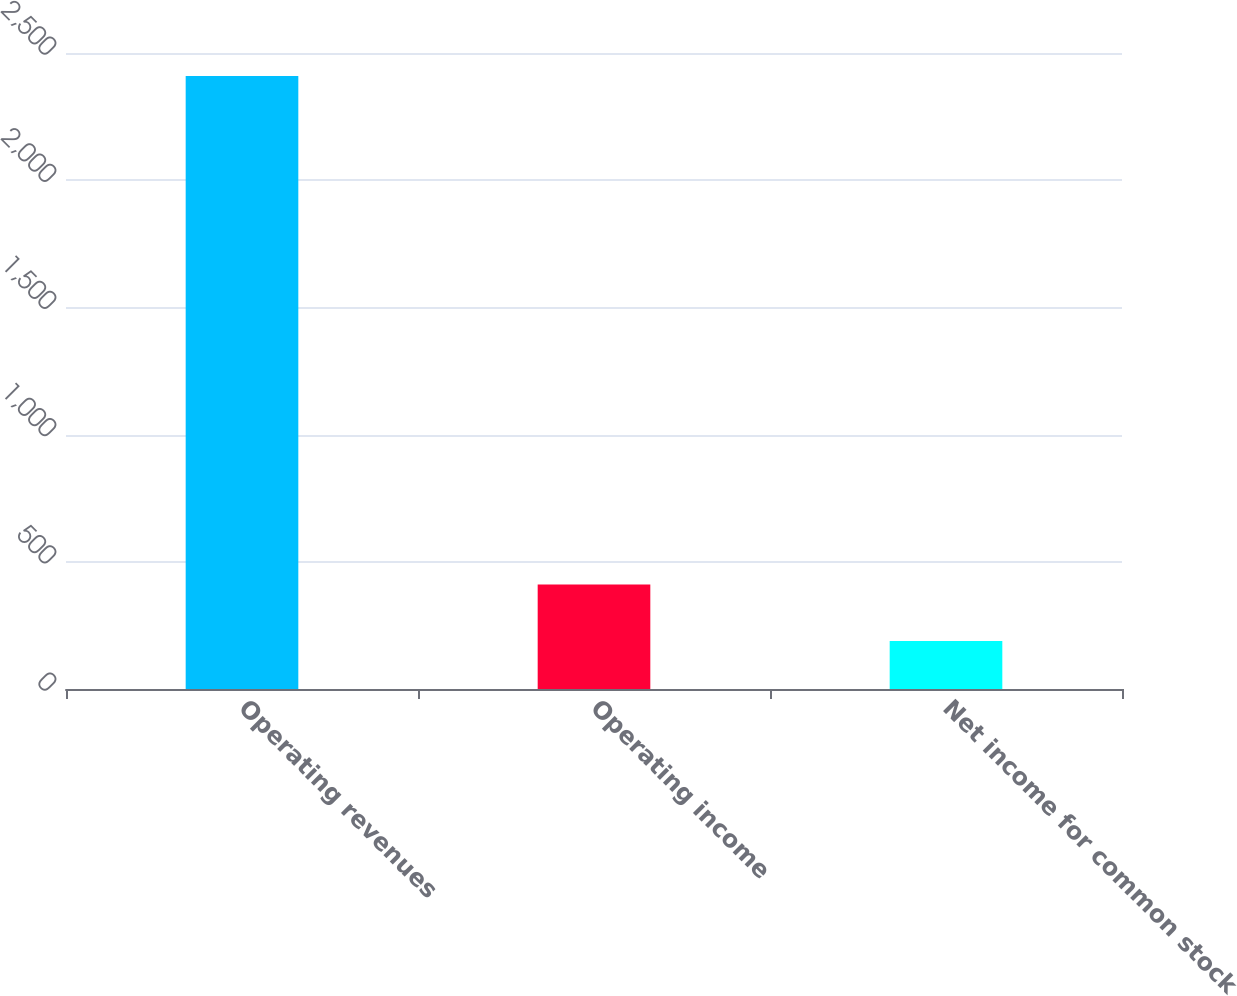<chart> <loc_0><loc_0><loc_500><loc_500><bar_chart><fcel>Operating revenues<fcel>Operating income<fcel>Net income for common stock<nl><fcel>2410<fcel>411.1<fcel>189<nl></chart> 